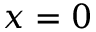Convert formula to latex. <formula><loc_0><loc_0><loc_500><loc_500>x = 0</formula> 